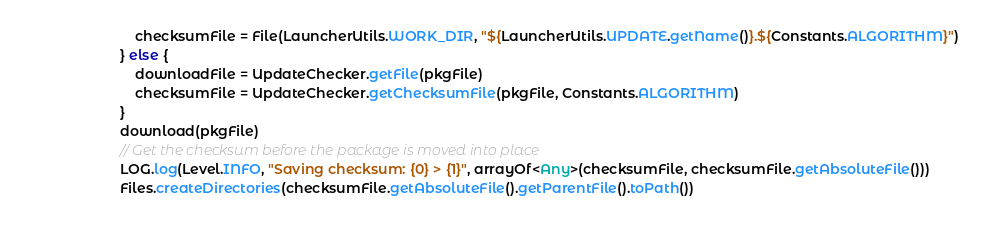<code> <loc_0><loc_0><loc_500><loc_500><_Kotlin_>                            checksumFile = File(LauncherUtils.WORK_DIR, "${LauncherUtils.UPDATE.getName()}.${Constants.ALGORITHM}")
                        } else {
                            downloadFile = UpdateChecker.getFile(pkgFile)
                            checksumFile = UpdateChecker.getChecksumFile(pkgFile, Constants.ALGORITHM)
                        }
                        download(pkgFile)
                        // Get the checksum before the package is moved into place
                        LOG.log(Level.INFO, "Saving checksum: {0} > {1}", arrayOf<Any>(checksumFile, checksumFile.getAbsoluteFile()))
                        Files.createDirectories(checksumFile.getAbsoluteFile().getParentFile().toPath())</code> 